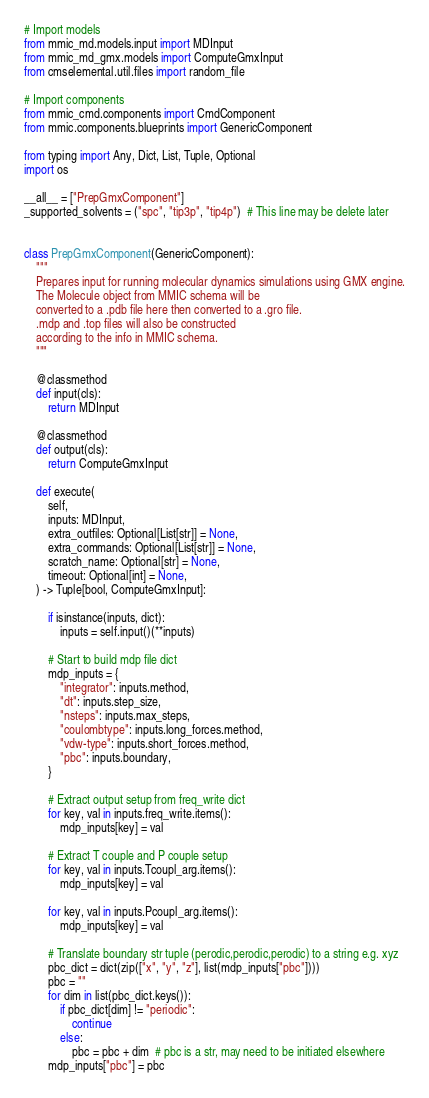<code> <loc_0><loc_0><loc_500><loc_500><_Python_># Import models
from mmic_md.models.input import MDInput
from mmic_md_gmx.models import ComputeGmxInput
from cmselemental.util.files import random_file

# Import components
from mmic_cmd.components import CmdComponent
from mmic.components.blueprints import GenericComponent

from typing import Any, Dict, List, Tuple, Optional
import os

__all__ = ["PrepGmxComponent"]
_supported_solvents = ("spc", "tip3p", "tip4p")  # This line may be delete later


class PrepGmxComponent(GenericComponent):
    """
    Prepares input for running molecular dynamics simulations using GMX engine.
    The Molecule object from MMIC schema will be
    converted to a .pdb file here then converted to a .gro file.
    .mdp and .top files will also be constructed
    according to the info in MMIC schema.
    """

    @classmethod
    def input(cls):
        return MDInput

    @classmethod
    def output(cls):
        return ComputeGmxInput

    def execute(
        self,
        inputs: MDInput,
        extra_outfiles: Optional[List[str]] = None,
        extra_commands: Optional[List[str]] = None,
        scratch_name: Optional[str] = None,
        timeout: Optional[int] = None,
    ) -> Tuple[bool, ComputeGmxInput]:

        if isinstance(inputs, dict):
            inputs = self.input()(**inputs)

        # Start to build mdp file dict
        mdp_inputs = {
            "integrator": inputs.method,
            "dt": inputs.step_size,
            "nsteps": inputs.max_steps,
            "coulombtype": inputs.long_forces.method,
            "vdw-type": inputs.short_forces.method,
            "pbc": inputs.boundary,
        }

        # Extract output setup from freq_write dict
        for key, val in inputs.freq_write.items():
            mdp_inputs[key] = val

        # Extract T couple and P couple setup
        for key, val in inputs.Tcoupl_arg.items():
            mdp_inputs[key] = val

        for key, val in inputs.Pcoupl_arg.items():
            mdp_inputs[key] = val

        # Translate boundary str tuple (perodic,perodic,perodic) to a string e.g. xyz
        pbc_dict = dict(zip(["x", "y", "z"], list(mdp_inputs["pbc"])))
        pbc = ""
        for dim in list(pbc_dict.keys()):
            if pbc_dict[dim] != "periodic":
                continue
            else:
                pbc = pbc + dim  # pbc is a str, may need to be initiated elsewhere
        mdp_inputs["pbc"] = pbc
</code> 